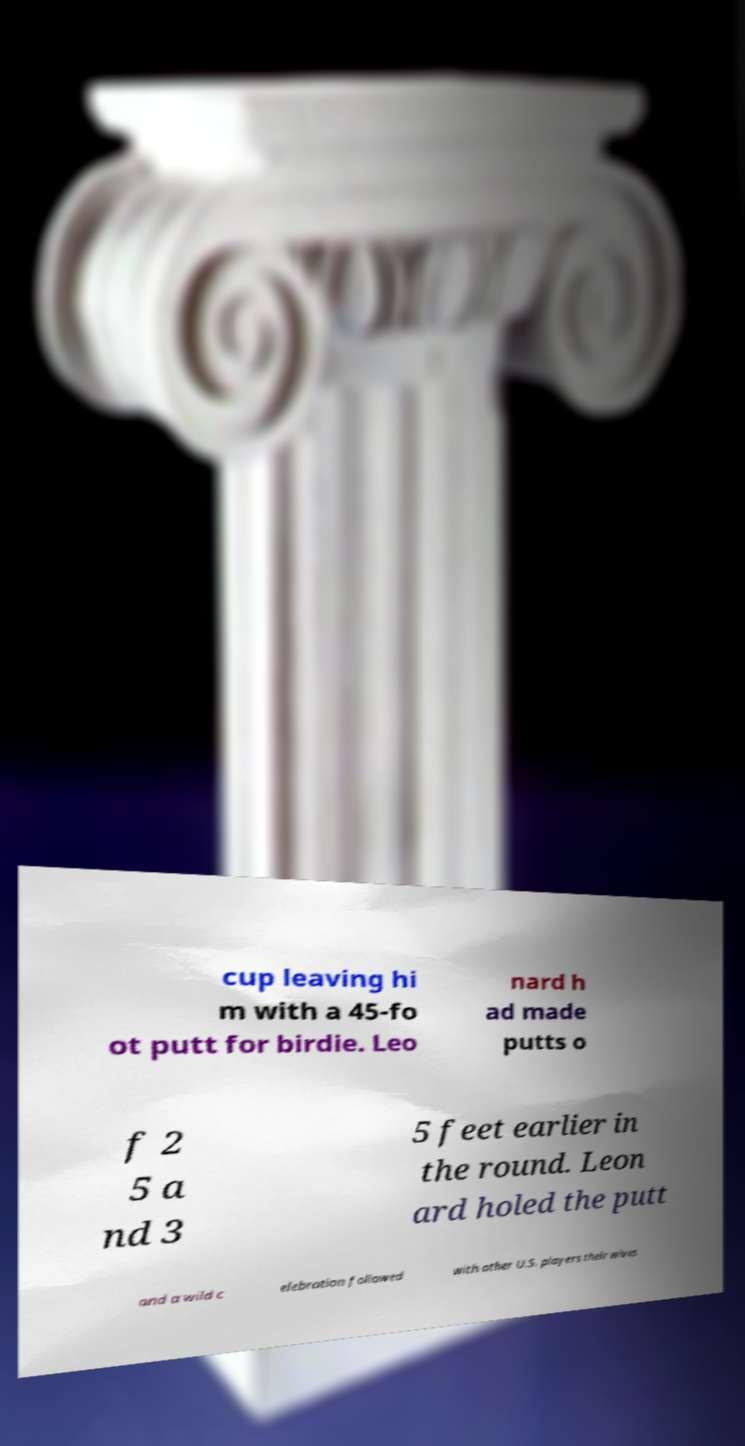Could you extract and type out the text from this image? cup leaving hi m with a 45-fo ot putt for birdie. Leo nard h ad made putts o f 2 5 a nd 3 5 feet earlier in the round. Leon ard holed the putt and a wild c elebration followed with other U.S. players their wives 